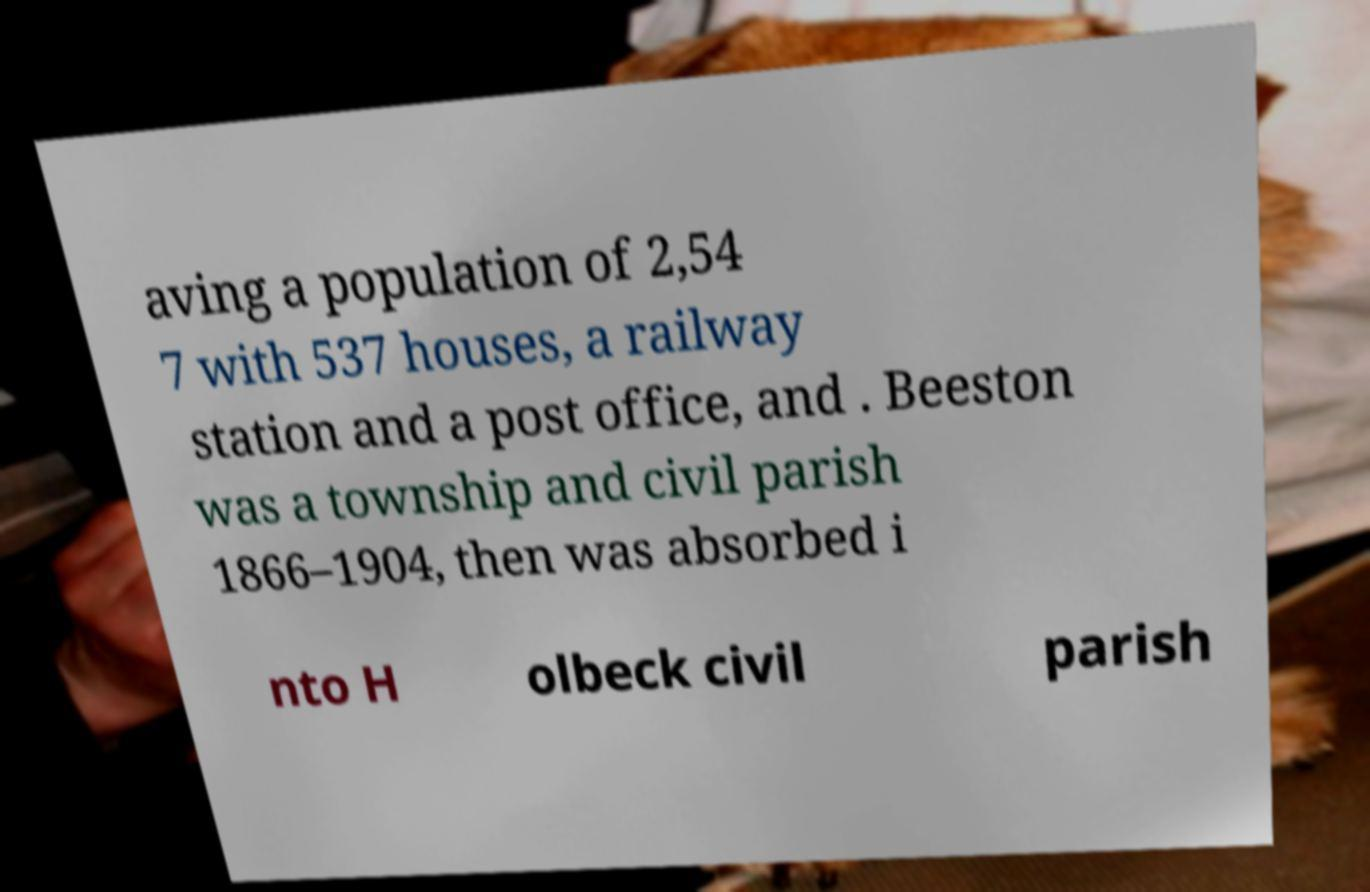What messages or text are displayed in this image? I need them in a readable, typed format. aving a population of 2,54 7 with 537 houses, a railway station and a post office, and . Beeston was a township and civil parish 1866–1904, then was absorbed i nto H olbeck civil parish 